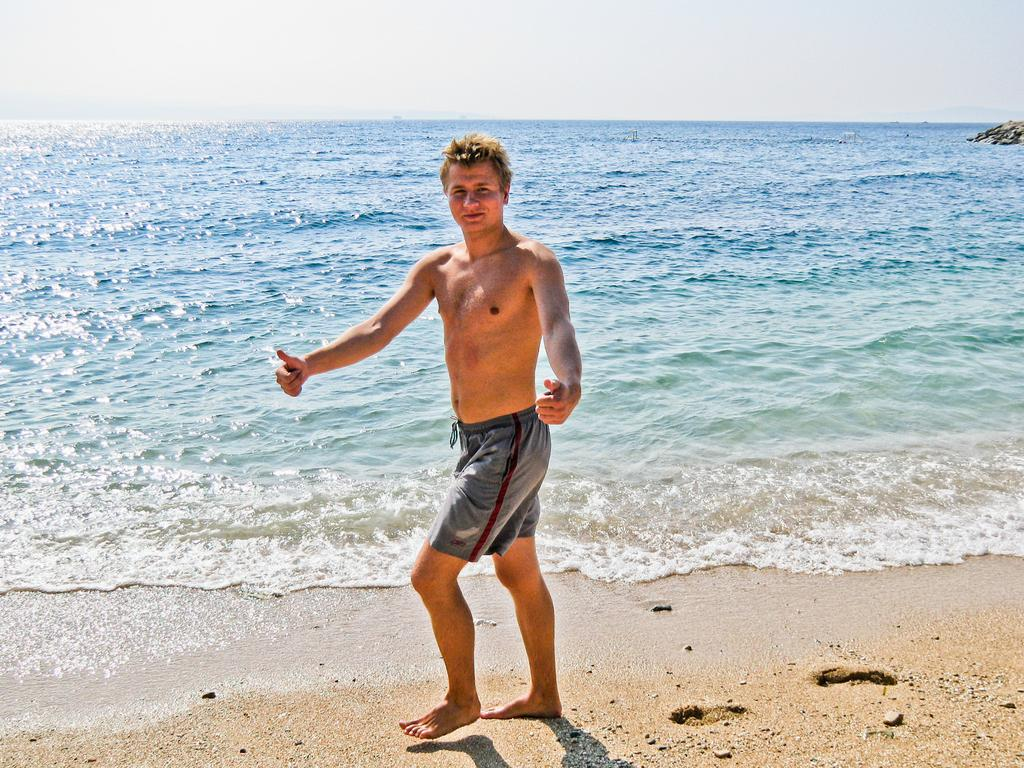What is the main subject in the front of the image? There is a person standing in the front of the image. What can be seen in the background of the image? There is an ocean in the background of the image. What type of objects are on the right side of the image? There are stones on the right side of the image. What type of pipe is visible in the image? There is no pipe present in the image. What offer is being made by the person in the image? The image does not depict any offer being made by the person. 